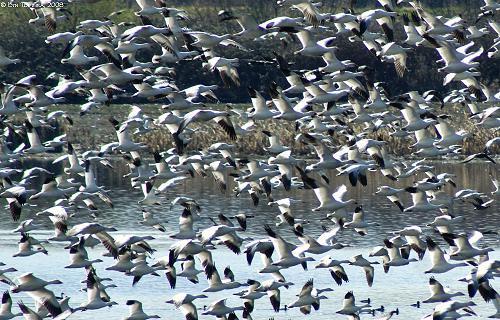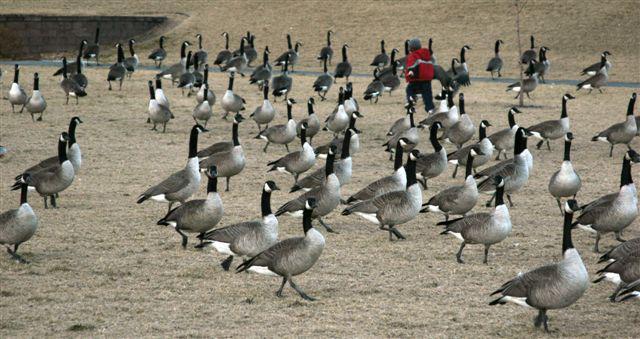The first image is the image on the left, the second image is the image on the right. Examine the images to the left and right. Is the description "Flocks of birds fly over water in at least one image." accurate? Answer yes or no. Yes. 